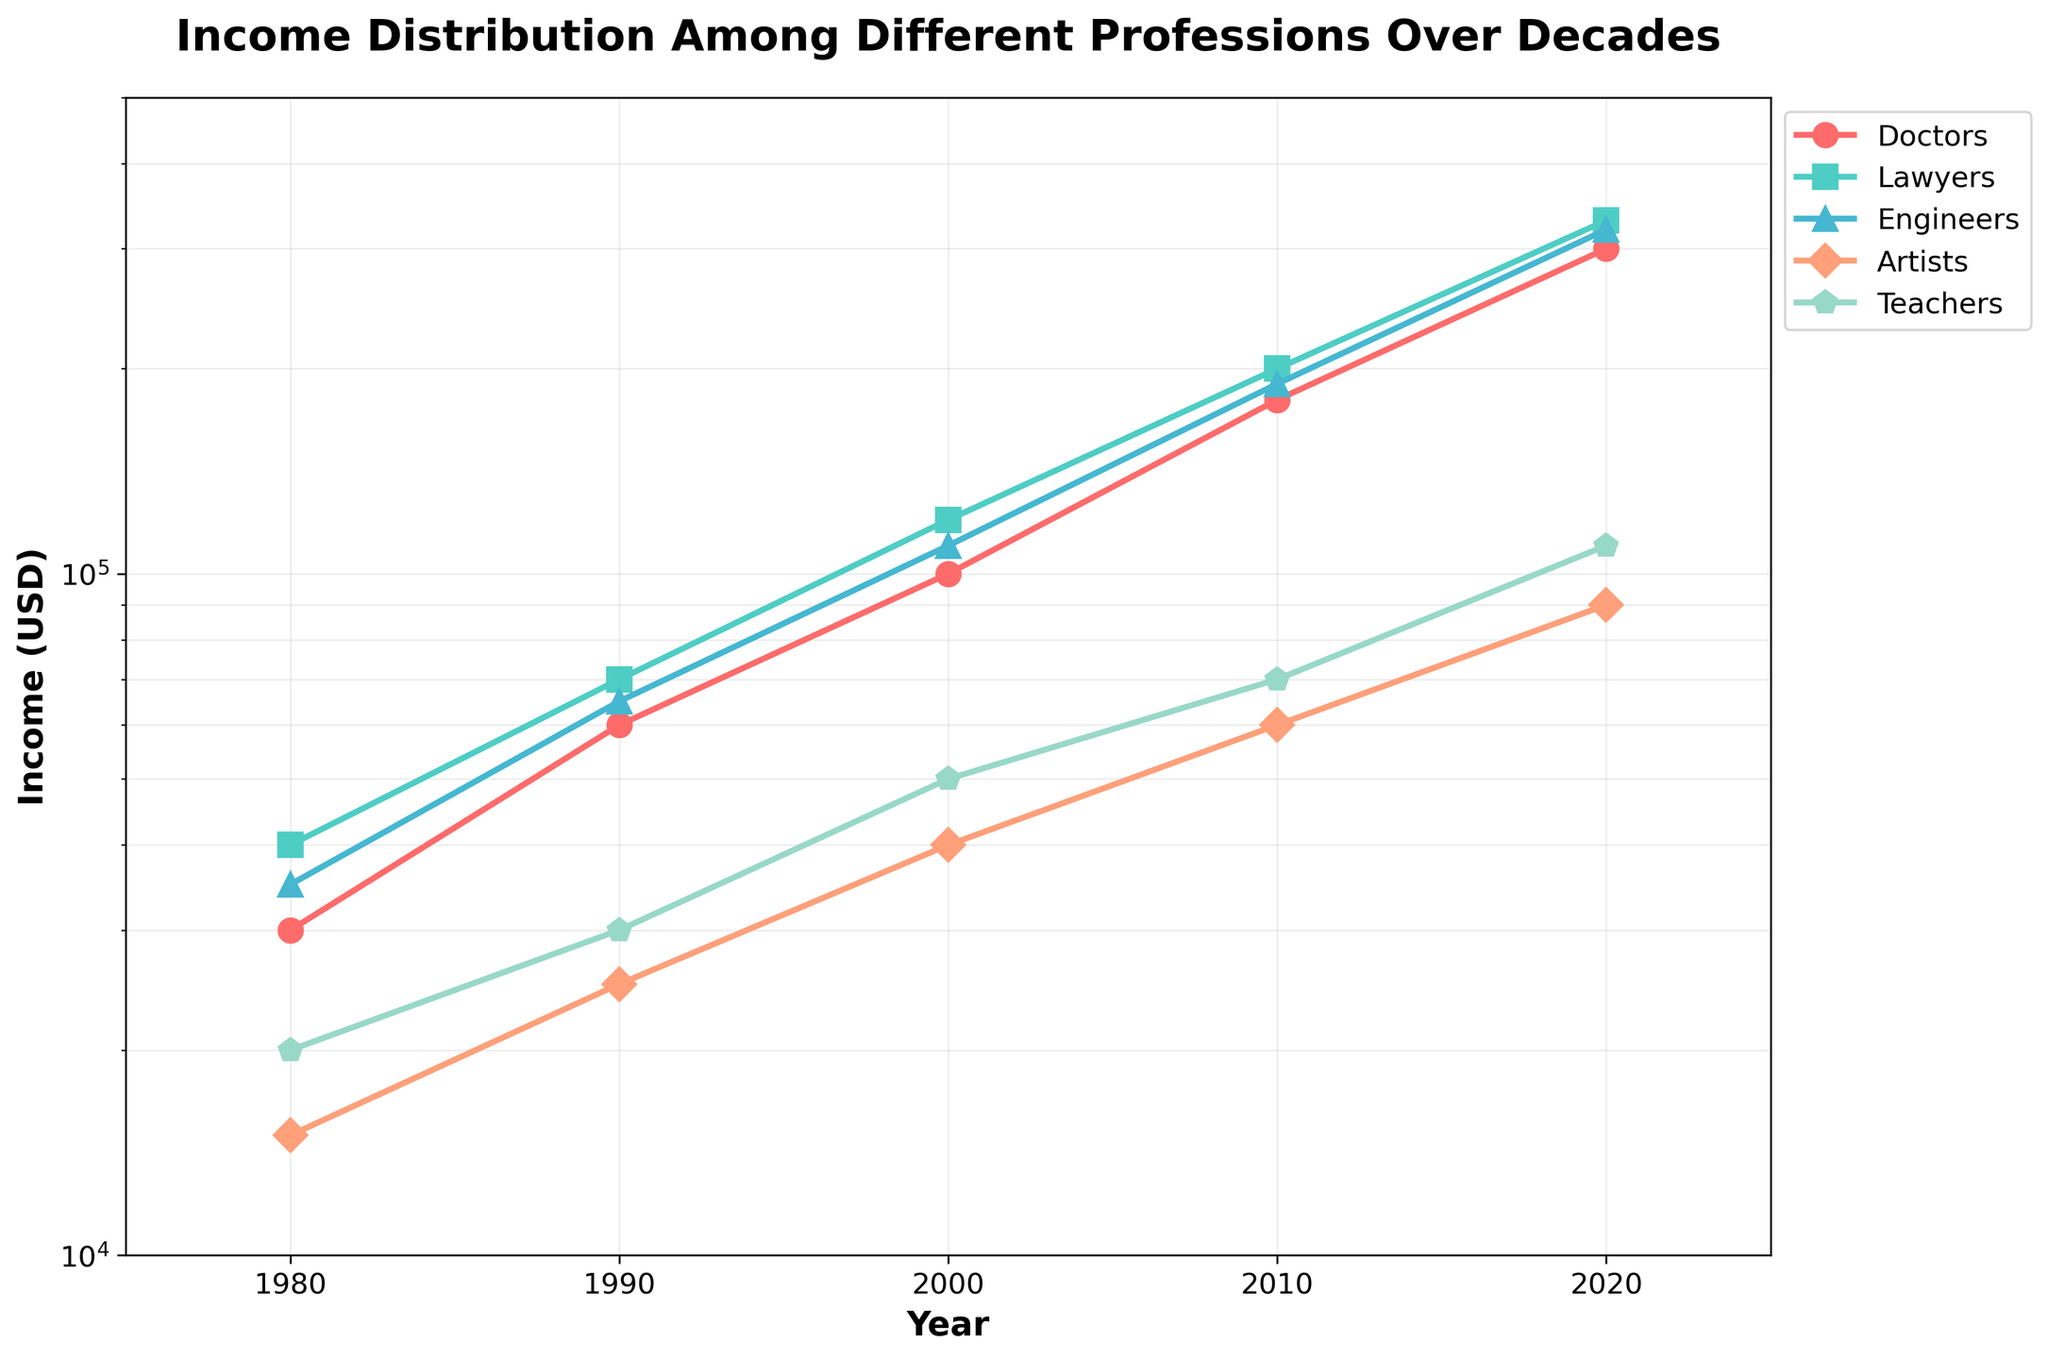What is the title of the plot? The title is located at the top center of the plot and is in a bold font. It gives an overview of what the plot represents.
Answer: Income Distribution Among Different Professions Over Decades What is the income value for Doctors in the year 2000? Locate the data point for Doctors in the year 2000 on the plot, and refer to the y-axis value, which is plotted on a log scale.
Answer: $100,000 Which profession had the highest income in 2020? At the year 2020 vertical line, find and compare the highest y-axis values among all professions.
Answer: Lawyers How has the income trend for Artists changed from 1980 to 2020? Track the data points for Artists from 1980 to 2020 and observe the direction and rate of change. The y-axis is on a log scale to highlight exponential changes.
Answer: It has increased from $15,000 to $90,000 By how much did the income of Engineers increase from 1990 to 2000? Identify the income values for Engineers in 1990 and 2000, then subtract the former from the latter.
Answer: $45,000 What is the ratio of Doctors' income to Teachers' income in 2010? Find the incomes for Doctors and Teachers in 2010 and then divide the former by the latter.
Answer: 2.57 Which profession experienced the largest absolute increase in income between 1980 and 2020? Calculate the difference between the 2020 and 1980 incomes for all professions, then identify the profession with the largest difference.
Answer: Doctors Which two professions have the smallest income gap in 2020? Compare the income values for all profession pairs in 2020 and find the smallest difference.
Answer: Engineers and Doctors How many professions are represented in the plot? The legend of the plot lists all the professions represented in the data lines. Count these entries.
Answer: Five professions Is the income growth for Teachers more or less consistent compared to Engineers? Compare the income trend lines for Teachers and Engineers from 1980 to 2020. Consistency can be judged by how smooth and steady the lines are without significant jumps or drops.
Answer: Less consistent 